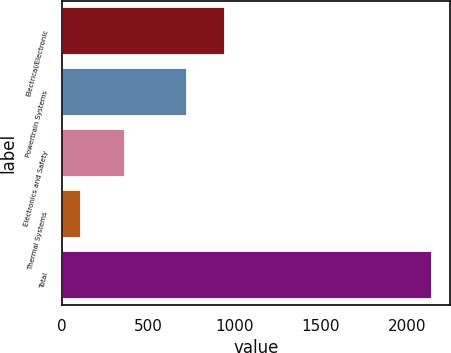Convert chart to OTSL. <chart><loc_0><loc_0><loc_500><loc_500><bar_chart><fcel>Electrical/Electronic<fcel>Powertrain Systems<fcel>Electronics and Safety<fcel>Thermal Systems<fcel>Total<nl><fcel>945<fcel>723<fcel>363<fcel>111<fcel>2142<nl></chart> 